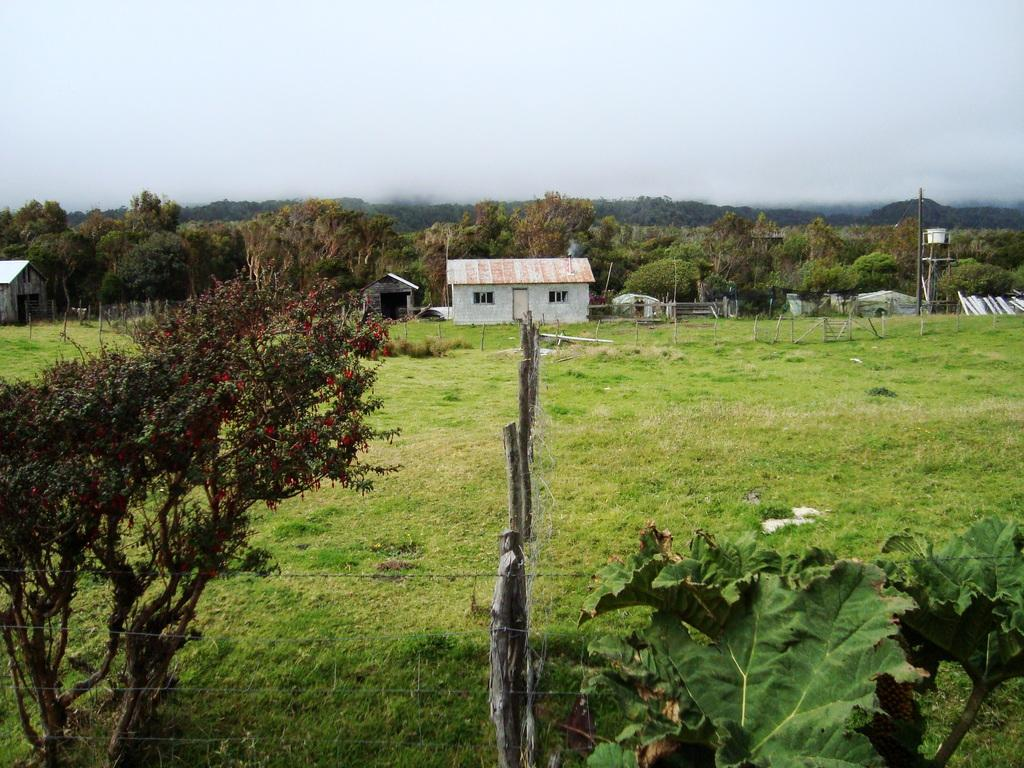What type of vegetation can be seen in the image? There are trees in the image. What type of structures are visible in the image? There are houses in the image. What type of barrier is present in the image? There is a fence in the image. What type of ground cover is present in the image? There is grass in the image. What type of vertical structures can be seen in the image? There are poles in the image. What is visible in the background of the image? The sky is visible in the background of the image. What type of quilt is being used to cover the scene in the image? There is no quilt present in the image; it features trees, houses, a fence, grass, poles, and the sky. What type of space vehicle can be seen in the image? There is no space vehicle present in the image; it features trees, houses, a fence, grass, poles, and the sky. 